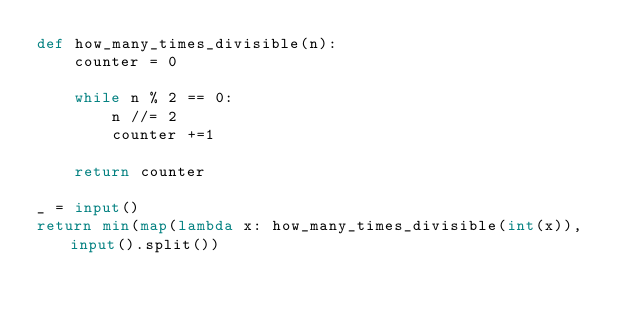Convert code to text. <code><loc_0><loc_0><loc_500><loc_500><_Python_>def how_many_times_divisible(n):
    counter = 0
	
    while n % 2 == 0:
    	n //= 2
        counter +=1
    
    return counter
  
_ = input()
return min(map(lambda x: how_many_times_divisible(int(x)), input().split())

</code> 